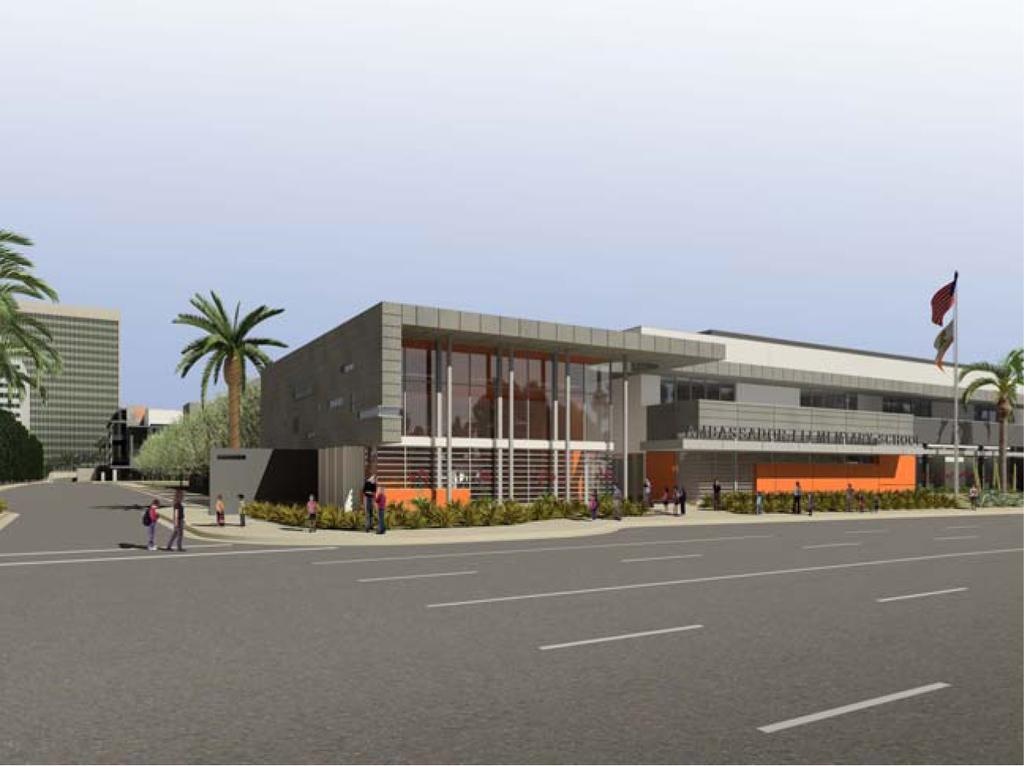Describe this image in one or two sentences. In the image we can see there are buildings in the area and there are people are standing on the road. There are lot of trees and in front of the building there is a flag. There is a clear sky on the top. 